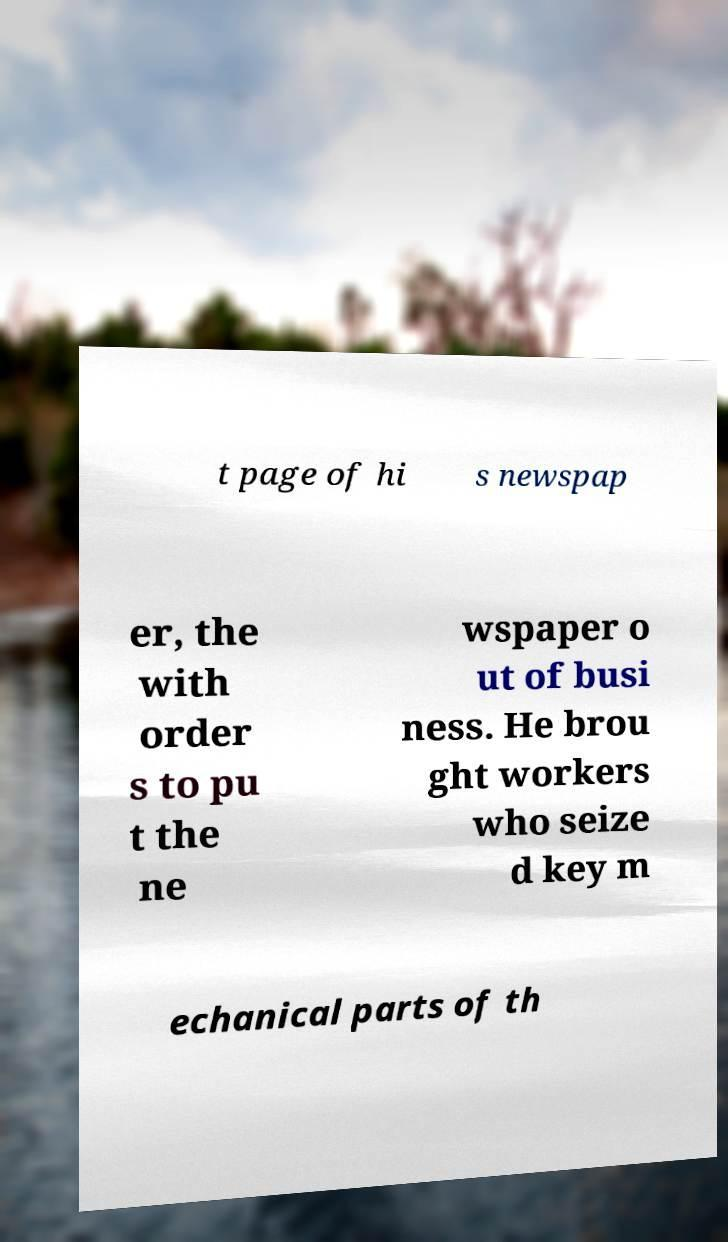Please identify and transcribe the text found in this image. t page of hi s newspap er, the with order s to pu t the ne wspaper o ut of busi ness. He brou ght workers who seize d key m echanical parts of th 